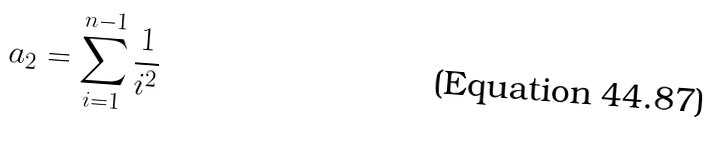<formula> <loc_0><loc_0><loc_500><loc_500>a _ { 2 } = \sum _ { i = 1 } ^ { n - 1 } \frac { 1 } { i ^ { 2 } }</formula> 